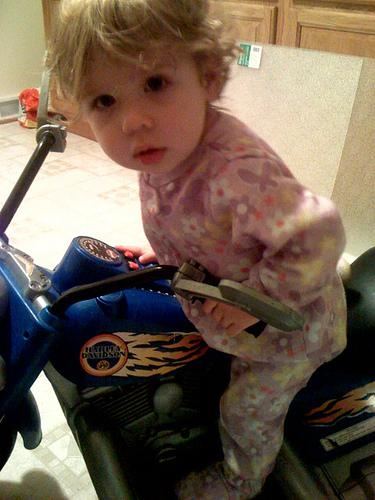Question: who is on the bike?
Choices:
A. A little boy.
B. A little girl.
C. A man.
D. A woman.
Answer with the letter. Answer: B Question: what is the little girl riding?
Choices:
A. Skateboard.
B. A scooter.
C. A pony.
D. A bike.
Answer with the letter. Answer: D Question: what brand is the bike modeled after?
Choices:
A. Yamaha.
B. Ducati.
C. Kawasaki.
D. Harley Davidson.
Answer with the letter. Answer: D Question: where is the picture taking place?
Choices:
A. In a restaurant.
B. In a house.
C. In an office.
D. In a club.
Answer with the letter. Answer: B 